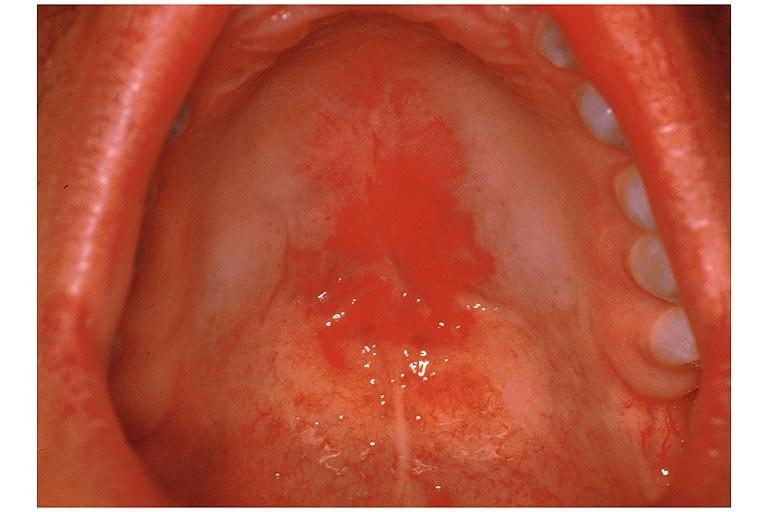does granulosa cell tumor show candidiasis-erythematous?
Answer the question using a single word or phrase. No 